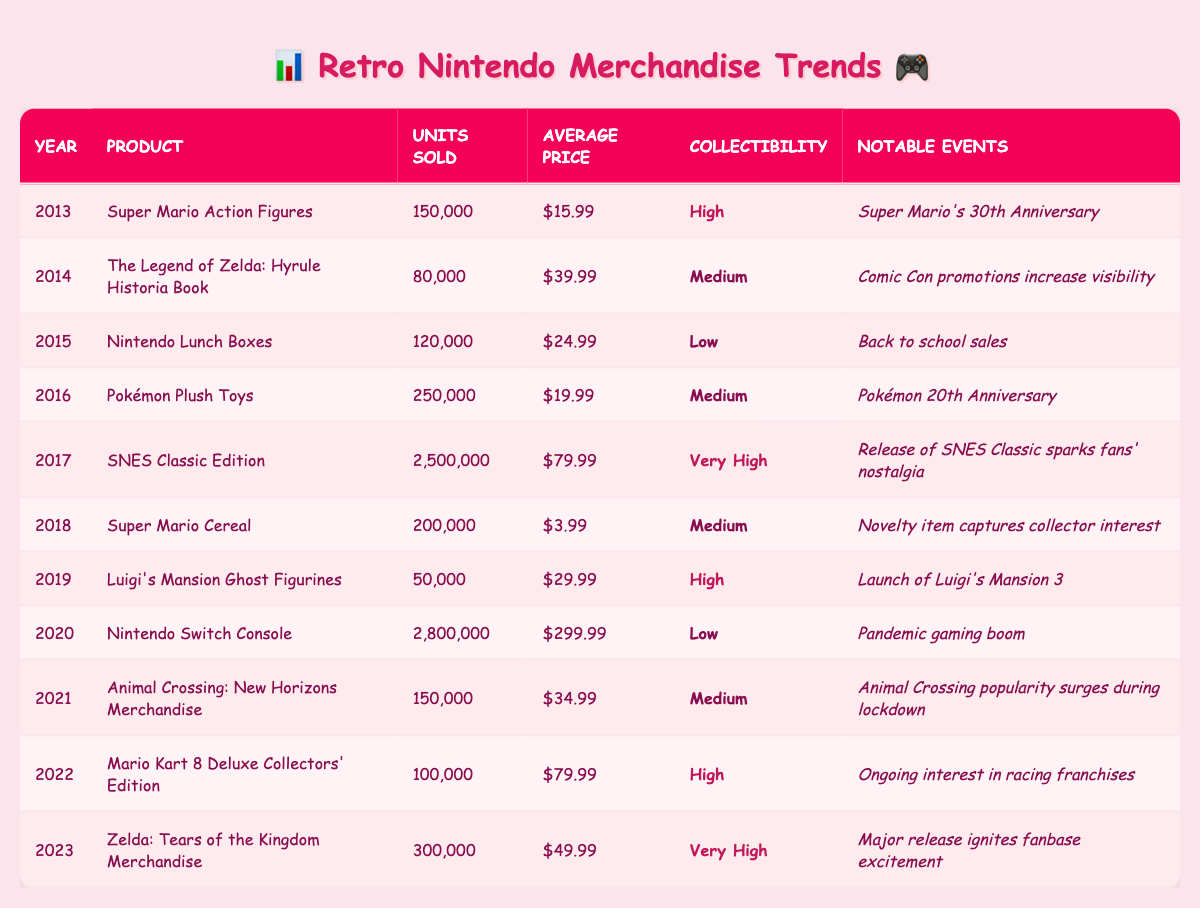What was the best-selling retro Nintendo product in 2017? The table shows that the SNES Classic Edition had the highest units sold at 2,500,000 in 2017.
Answer: SNES Classic Edition How many units of Pokémon Plush Toys were sold in 2016? According to the table, Pokémon Plush Toys sold 250,000 units in 2016.
Answer: 250,000 Which year saw the release of the Nintendo Switch Console, which had a high sales figure? The table indicates that the Nintendo Switch Console was released in 2020 with 2,800,000 units sold.
Answer: 2020 What was the average price of Super Mario Cereal sold in 2018? The table lists the average price of Super Mario Cereal as $3.99 in 2018.
Answer: $3.99 In which year did the Luigis's Mansion Ghost Figurines sell the fewest units? By looking at the table, it's evident that Luigi's Mansion Ghost Figurines had the lowest sales at 50,000 units in 2019.
Answer: 2019 What was the total number of units sold for retro Nintendo merchandise in 2013 and 2014 combined? The total for 2013 (150,000) and 2014 (80,000) is 150,000 + 80,000 = 230,000 units.
Answer: 230,000 Did Super Mario Action Figures have a higher collectibility rating than Nintendo Lunch Boxes? Super Mario Action Figures had a "High" rating while Nintendo Lunch Boxes had a "Low" rating, so yes, it is true that Super Mario Action Figures had a higher collectibility.
Answer: Yes Which product had the highest average price in 2020? The Nintendo Switch Console had the highest average price at $299.99 in 2020 compared to other products that year.
Answer: Nintendo Switch Console What is the trend of units sold from 2013 to 2023? Analyzing the table shows that units sold generally increased, with a peak in 2017 (2,500,000) and then fluctuating but remaining high, particularly with the Nintendo Switch in 2020 and Zelda merchandise in 2023.
Answer: Increasing trend What was the notable event linked to the sales of Zelda merchandise in 2023? The table indicates that the major release of "Zelda: Tears of the Kingdom Merchandise" in 2023 ignited fanbase excitement.
Answer: Major release ignites fanbase excitement 